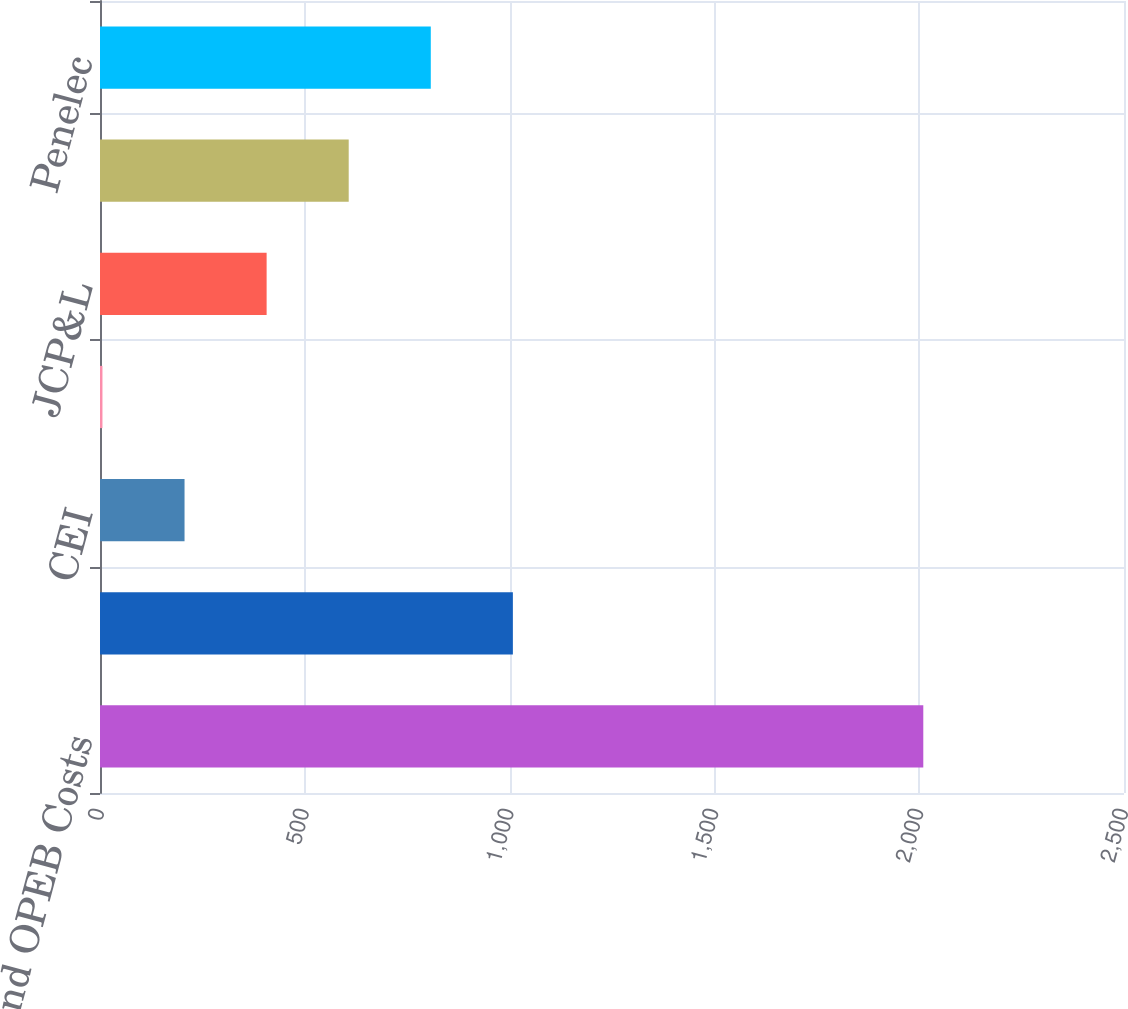Convert chart to OTSL. <chart><loc_0><loc_0><loc_500><loc_500><bar_chart><fcel>and OPEB Costs<fcel>OE<fcel>CEI<fcel>TE<fcel>JCP&L<fcel>Met-Ed<fcel>Penelec<nl><fcel>2010<fcel>1008<fcel>206.4<fcel>6<fcel>406.8<fcel>607.2<fcel>807.6<nl></chart> 